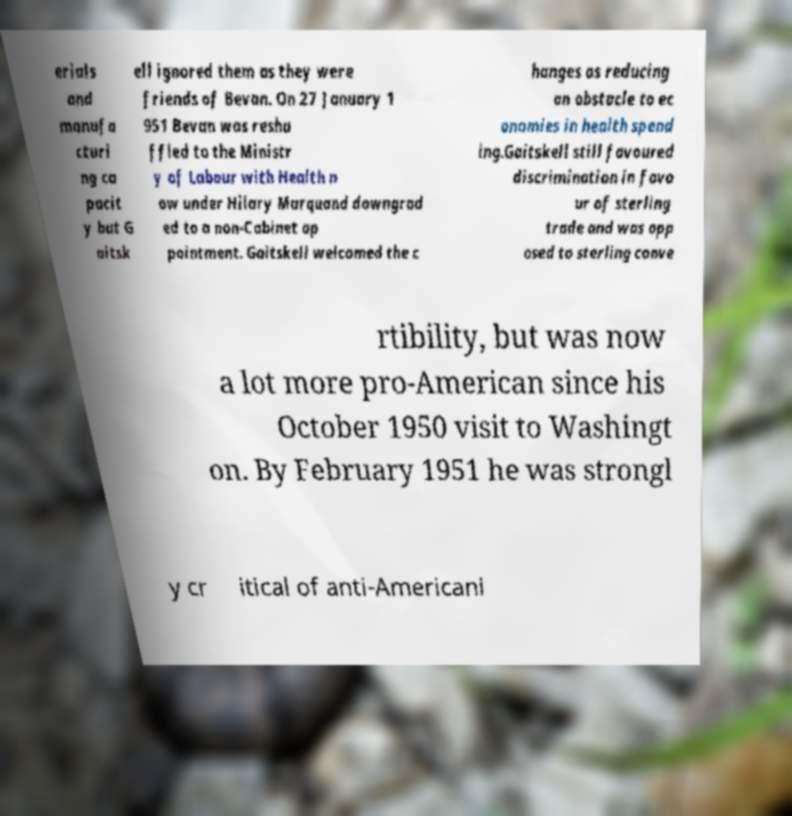Please identify and transcribe the text found in this image. erials and manufa cturi ng ca pacit y but G aitsk ell ignored them as they were friends of Bevan. On 27 January 1 951 Bevan was reshu ffled to the Ministr y of Labour with Health n ow under Hilary Marquand downgrad ed to a non-Cabinet ap pointment. Gaitskell welcomed the c hanges as reducing an obstacle to ec onomies in health spend ing.Gaitskell still favoured discrimination in favo ur of sterling trade and was opp osed to sterling conve rtibility, but was now a lot more pro-American since his October 1950 visit to Washingt on. By February 1951 he was strongl y cr itical of anti-Americani 